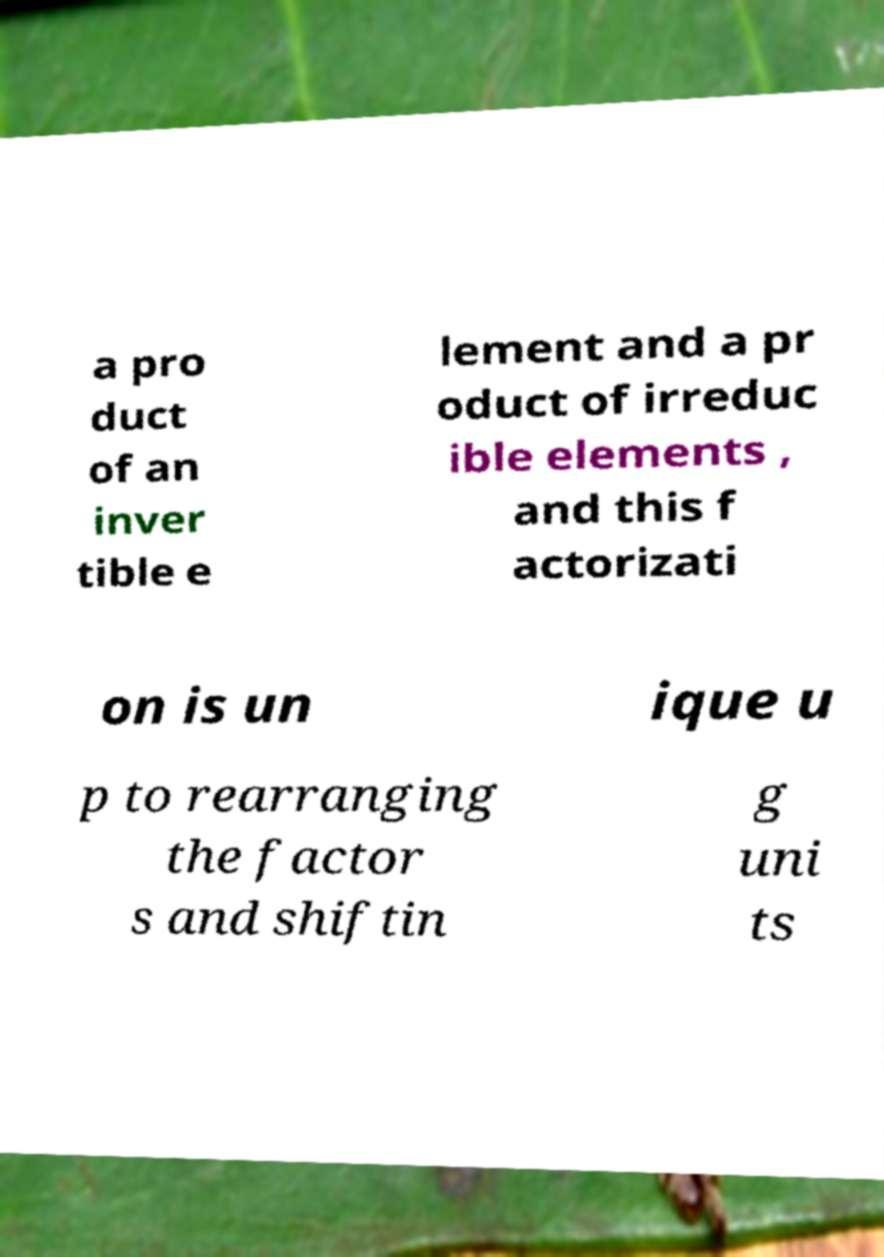There's text embedded in this image that I need extracted. Can you transcribe it verbatim? a pro duct of an inver tible e lement and a pr oduct of irreduc ible elements , and this f actorizati on is un ique u p to rearranging the factor s and shiftin g uni ts 